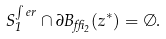Convert formula to latex. <formula><loc_0><loc_0><loc_500><loc_500>S _ { 1 } ^ { \int e r } \cap \partial B _ { \delta _ { 2 } } ( z ^ { * } ) = \emptyset .</formula> 